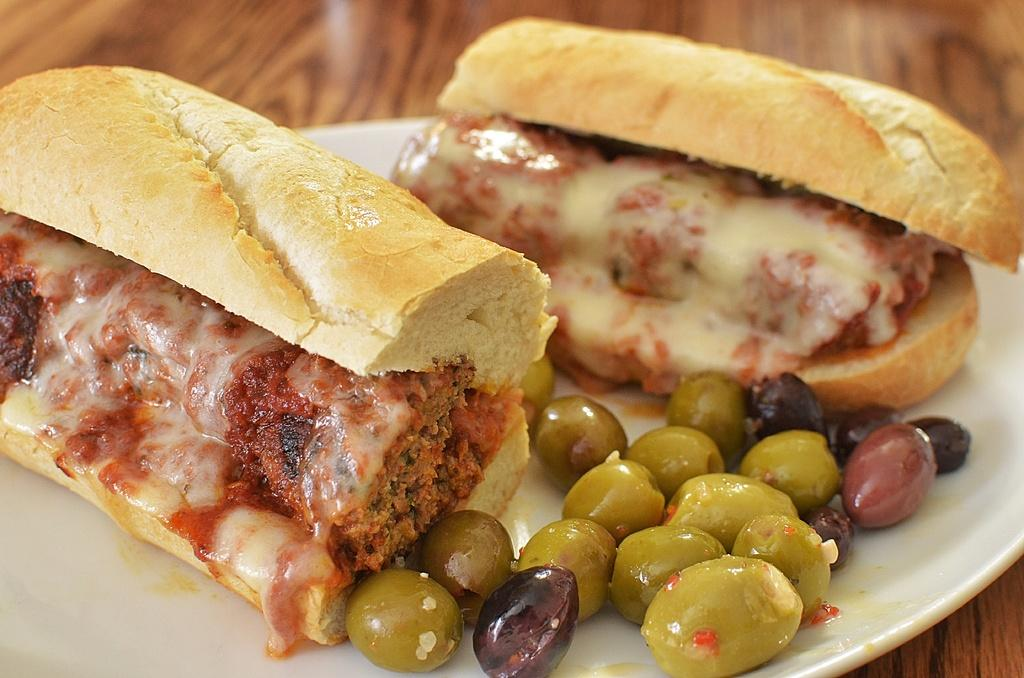What is on the plate that is visible in the image? There is a plate with food in the image. Where is the plate located in the image? The plate is on a wooden platform. What type of thrill can be experienced by the dolls on the shelf in the image? There are no dolls or shelves present in the image. 